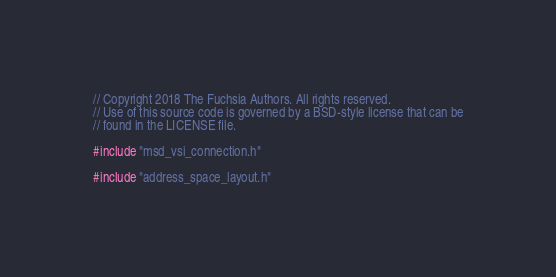<code> <loc_0><loc_0><loc_500><loc_500><_C++_>// Copyright 2018 The Fuchsia Authors. All rights reserved.
// Use of this source code is governed by a BSD-style license that can be
// found in the LICENSE file.

#include "msd_vsi_connection.h"

#include "address_space_layout.h"</code> 